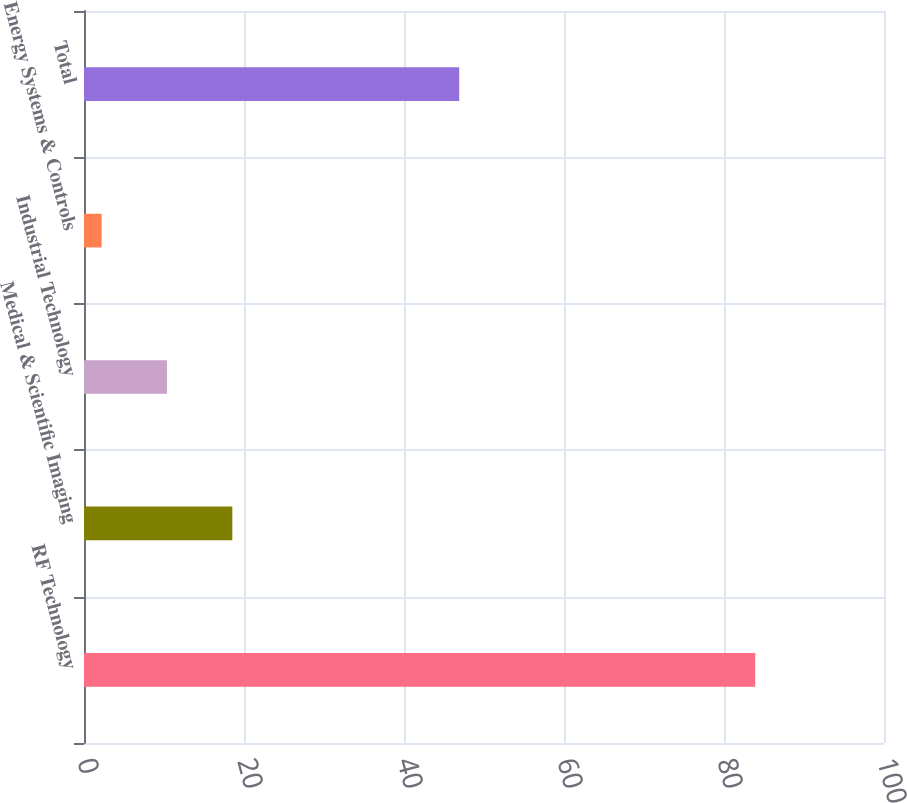<chart> <loc_0><loc_0><loc_500><loc_500><bar_chart><fcel>RF Technology<fcel>Medical & Scientific Imaging<fcel>Industrial Technology<fcel>Energy Systems & Controls<fcel>Total<nl><fcel>83.9<fcel>18.54<fcel>10.37<fcel>2.2<fcel>46.9<nl></chart> 